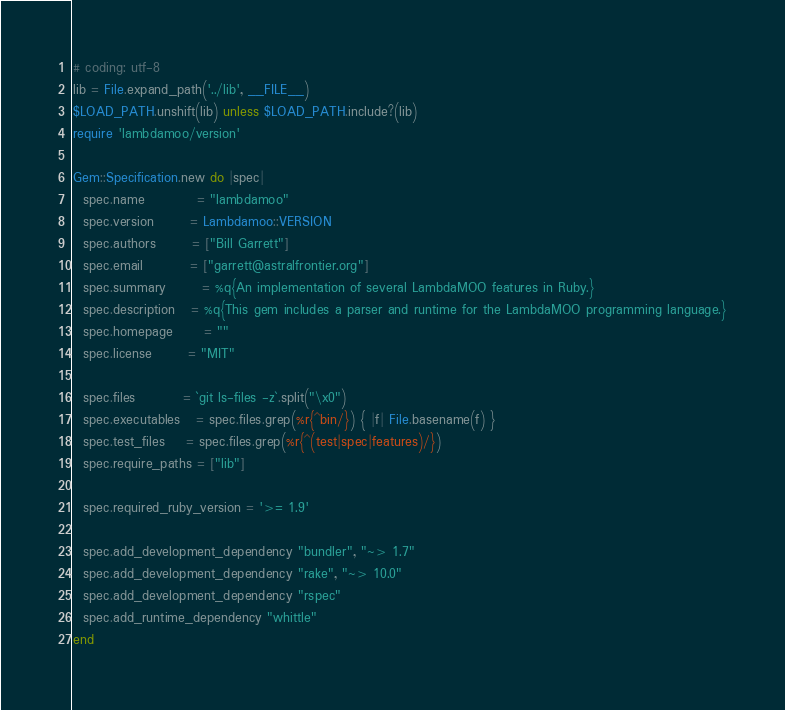Convert code to text. <code><loc_0><loc_0><loc_500><loc_500><_Ruby_># coding: utf-8
lib = File.expand_path('../lib', __FILE__)
$LOAD_PATH.unshift(lib) unless $LOAD_PATH.include?(lib)
require 'lambdamoo/version'

Gem::Specification.new do |spec|
  spec.name          = "lambdamoo"
  spec.version       = Lambdamoo::VERSION
  spec.authors       = ["Bill Garrett"]
  spec.email         = ["garrett@astralfrontier.org"]
  spec.summary       = %q{An implementation of several LambdaMOO features in Ruby.}
  spec.description   = %q{This gem includes a parser and runtime for the LambdaMOO programming language.}
  spec.homepage      = ""
  spec.license       = "MIT"

  spec.files         = `git ls-files -z`.split("\x0")
  spec.executables   = spec.files.grep(%r{^bin/}) { |f| File.basename(f) }
  spec.test_files    = spec.files.grep(%r{^(test|spec|features)/})
  spec.require_paths = ["lib"]

  spec.required_ruby_version = '>= 1.9'

  spec.add_development_dependency "bundler", "~> 1.7"
  spec.add_development_dependency "rake", "~> 10.0"
  spec.add_development_dependency "rspec"
  spec.add_runtime_dependency "whittle"
end
</code> 